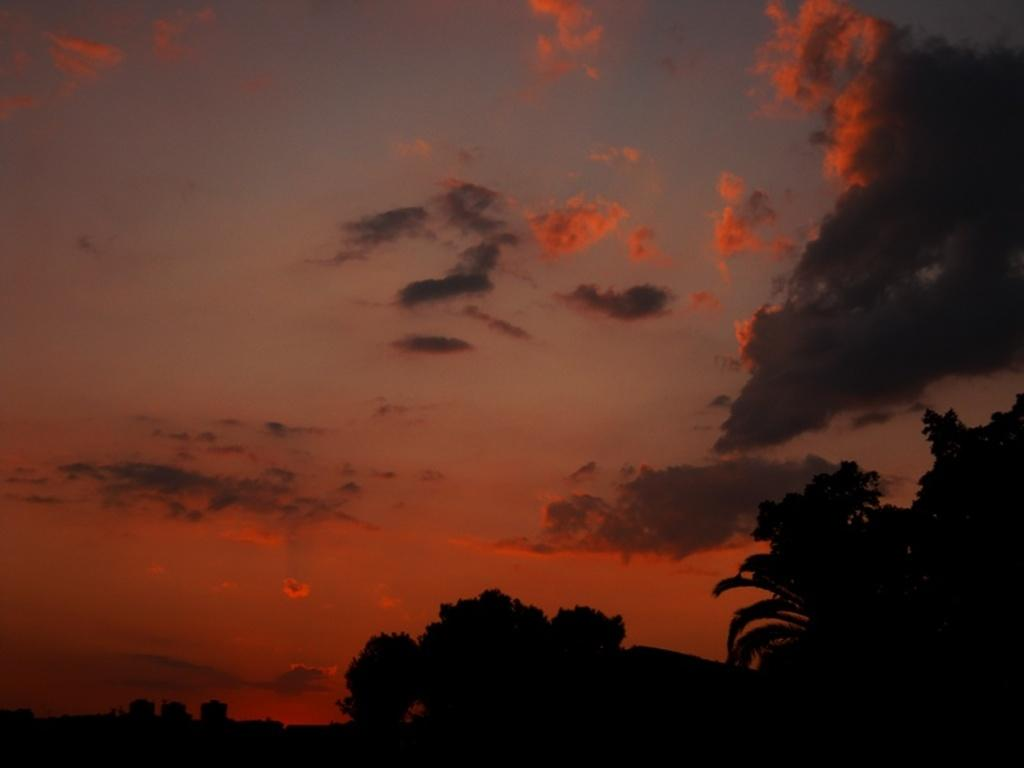What type of vegetation is present in the image? There are many trees in the image. What can be seen in the background of the image? There are clouds and the sky visible in the background of the image. What is the color of some of the clouds in the image? Some clouds have an orange color. How many shelves are visible in the image? There are no shelves present in the image. What force is being applied to the trees in the image? There is no force being applied to the trees in the image; they are stationary. 